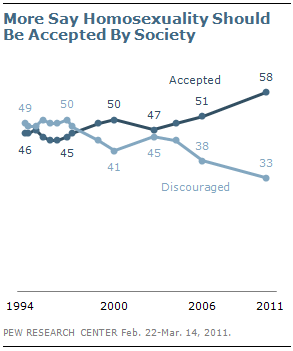Outline some significant characteristics in this image. If the largest difference and smallest difference between two lines are divided, the result is 12.5. What is the value of Accepted graph in 2011? It is 58. 